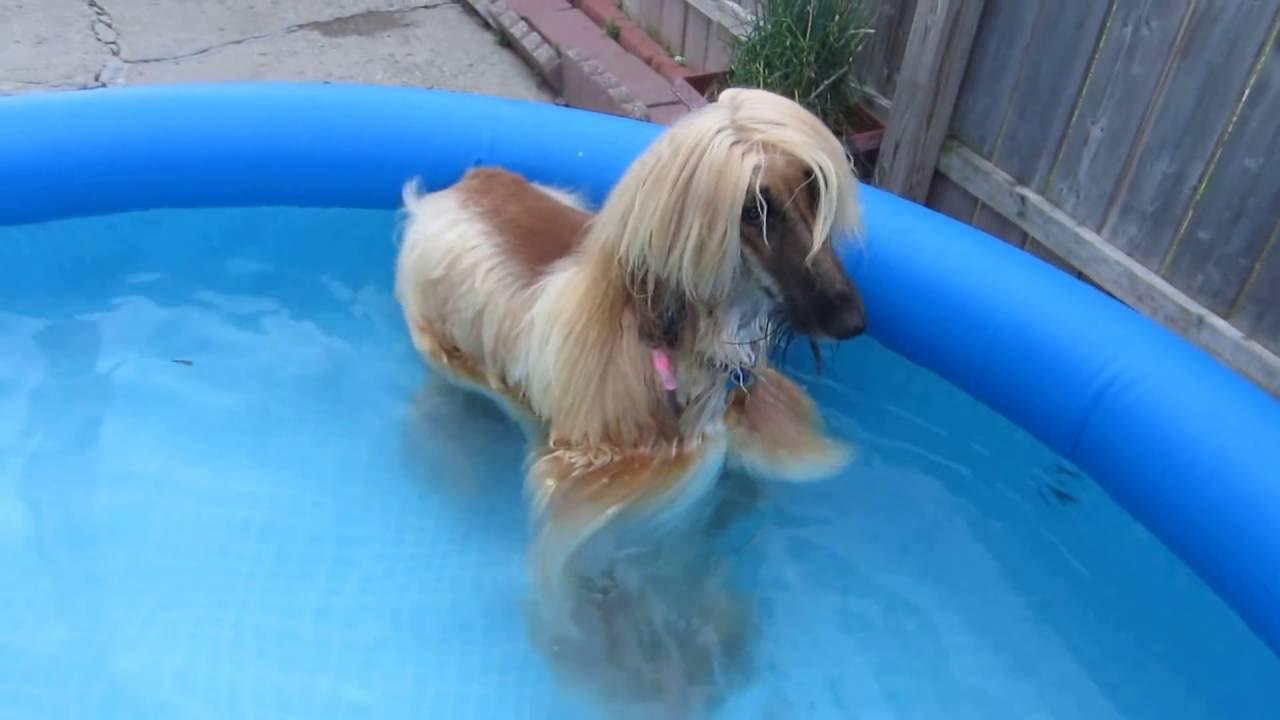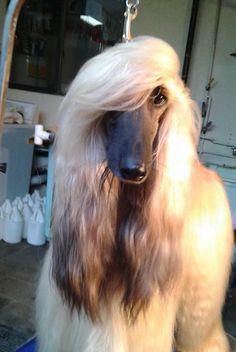The first image is the image on the left, the second image is the image on the right. Evaluate the accuracy of this statement regarding the images: "One image shows a dog underwater and sideways, with its head to the left and its long fur trailing rightward.". Is it true? Answer yes or no. No. The first image is the image on the left, the second image is the image on the right. Evaluate the accuracy of this statement regarding the images: "A dog is completely submerged in the water.". Is it true? Answer yes or no. No. 